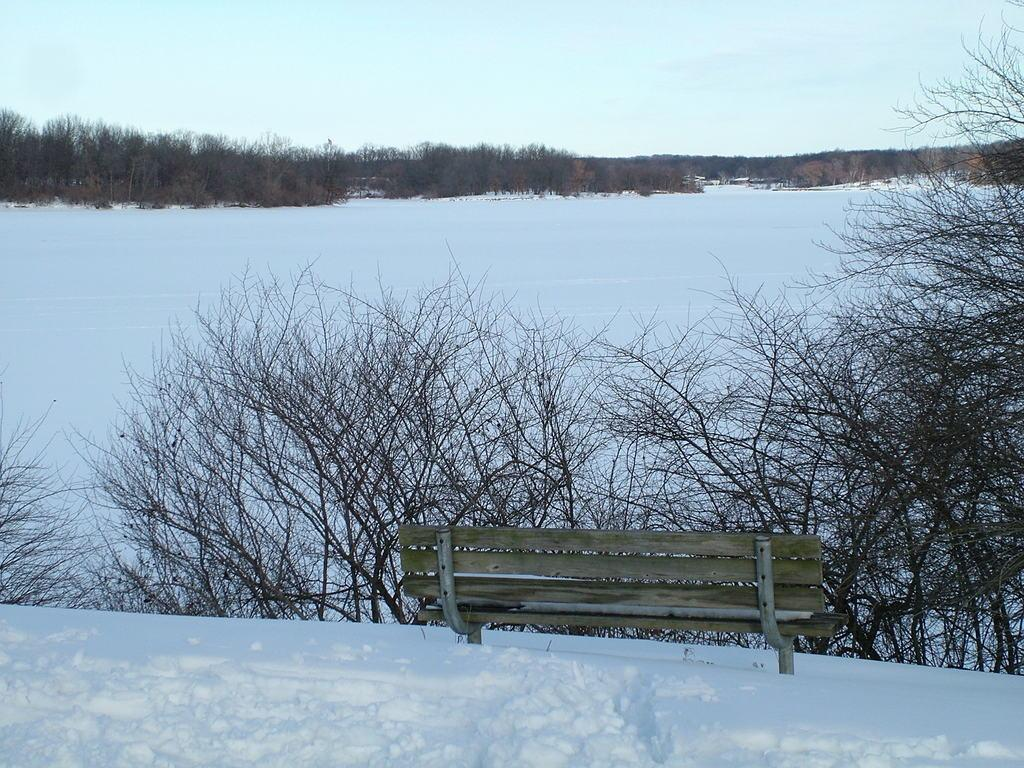What type of seating is present in the image? There is a bench in the image. What type of vegetation can be seen in the image? There are trees in the image. What type of landscape feature is visible in the image? There are hills in the image. What is covering the ground at the bottom of the image? There is snow at the bottom of the image. What is visible at the top of the image? The sky is visible at the top of the image. Can you tell me where the key is hidden in the image? There is no key present in the image. What type of animal can be seen grazing on the hill in the image? There is no animal, such as a goat, present in the image. 